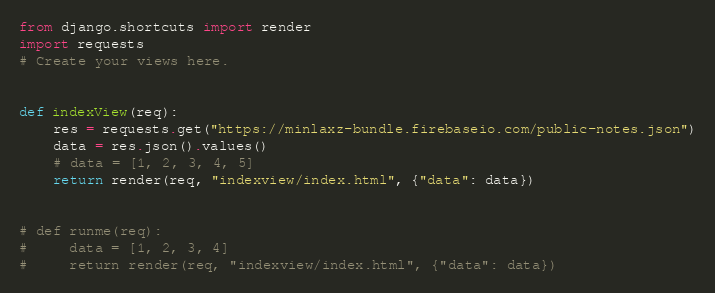Convert code to text. <code><loc_0><loc_0><loc_500><loc_500><_Python_>from django.shortcuts import render
import requests
# Create your views here.


def indexView(req):
    res = requests.get("https://minlaxz-bundle.firebaseio.com/public-notes.json")
    data = res.json().values()
    # data = [1, 2, 3, 4, 5]
    return render(req, "indexview/index.html", {"data": data})


# def runme(req):
#     data = [1, 2, 3, 4]
#     return render(req, "indexview/index.html", {"data": data})</code> 